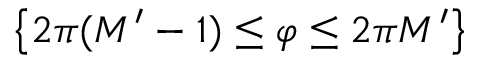Convert formula to latex. <formula><loc_0><loc_0><loc_500><loc_500>\left \{ 2 \pi ( M ^ { \prime } - 1 ) \leq \varphi \leq 2 \pi M ^ { \prime } \right \}</formula> 